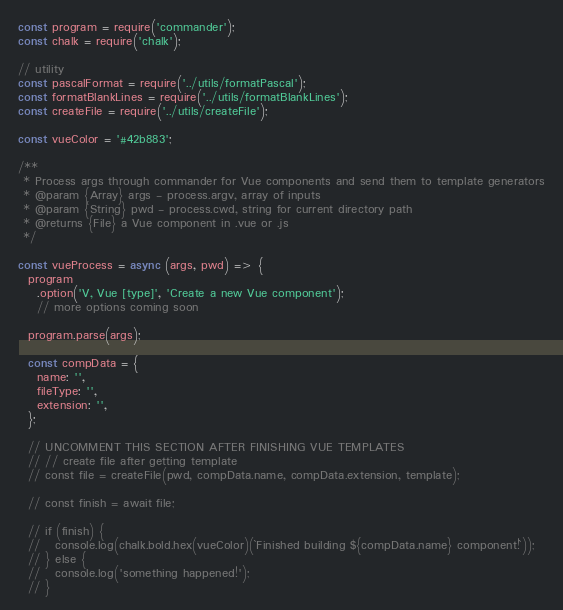<code> <loc_0><loc_0><loc_500><loc_500><_JavaScript_>const program = require('commander');
const chalk = require('chalk');

// utility
const pascalFormat = require('../utils/formatPascal');
const formatBlankLines = require('../utils/formatBlankLines');
const createFile = require('../utils/createFile');

const vueColor = '#42b883';

/**
 * Process args through commander for Vue components and send them to template generators
 * @param {Array} args - process.argv, array of inputs
 * @param {String} pwd - process.cwd, string for current directory path
 * @returns {File} a Vue component in .vue or .js
 */

const vueProcess = async (args, pwd) => {
  program
    .option('V, Vue [type]', 'Create a new Vue component');
    // more options coming soon

  program.parse(args);

  const compData = {
    name: '',
    fileType: '',
    extension: '',
  };

  // UNCOMMENT THIS SECTION AFTER FINISHING VUE TEMPLATES
  // // create file after getting template
  // const file = createFile(pwd, compData.name, compData.extension, template);

  // const finish = await file;

  // if (finish) {
  //   console.log(chalk.bold.hex(vueColor)(`Finished building ${compData.name} component!`));
  // } else {
  //   console.log('something happened!');
  // }
</code> 